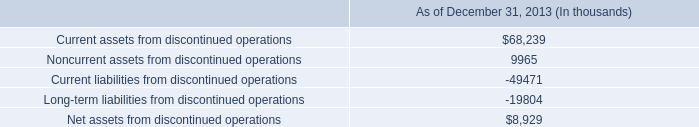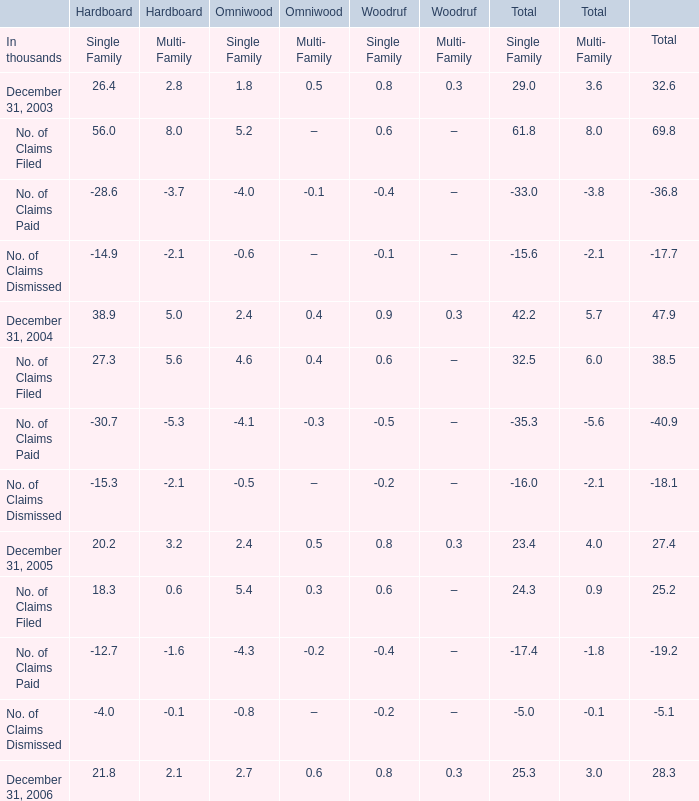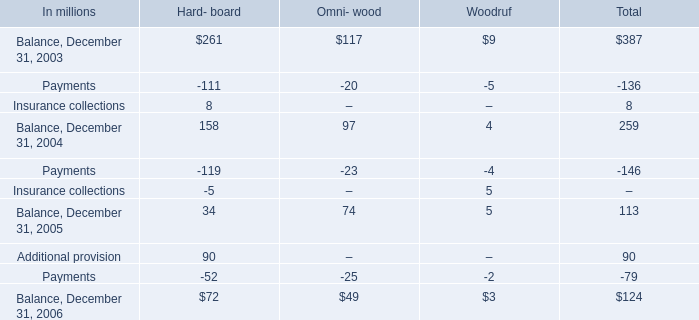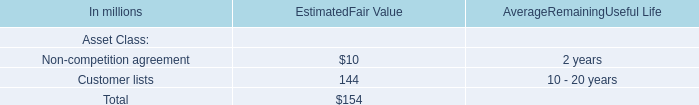what is the tax expense related to discontinued operations in 2013? 
Computations: (54 - 47)
Answer: 7.0. 